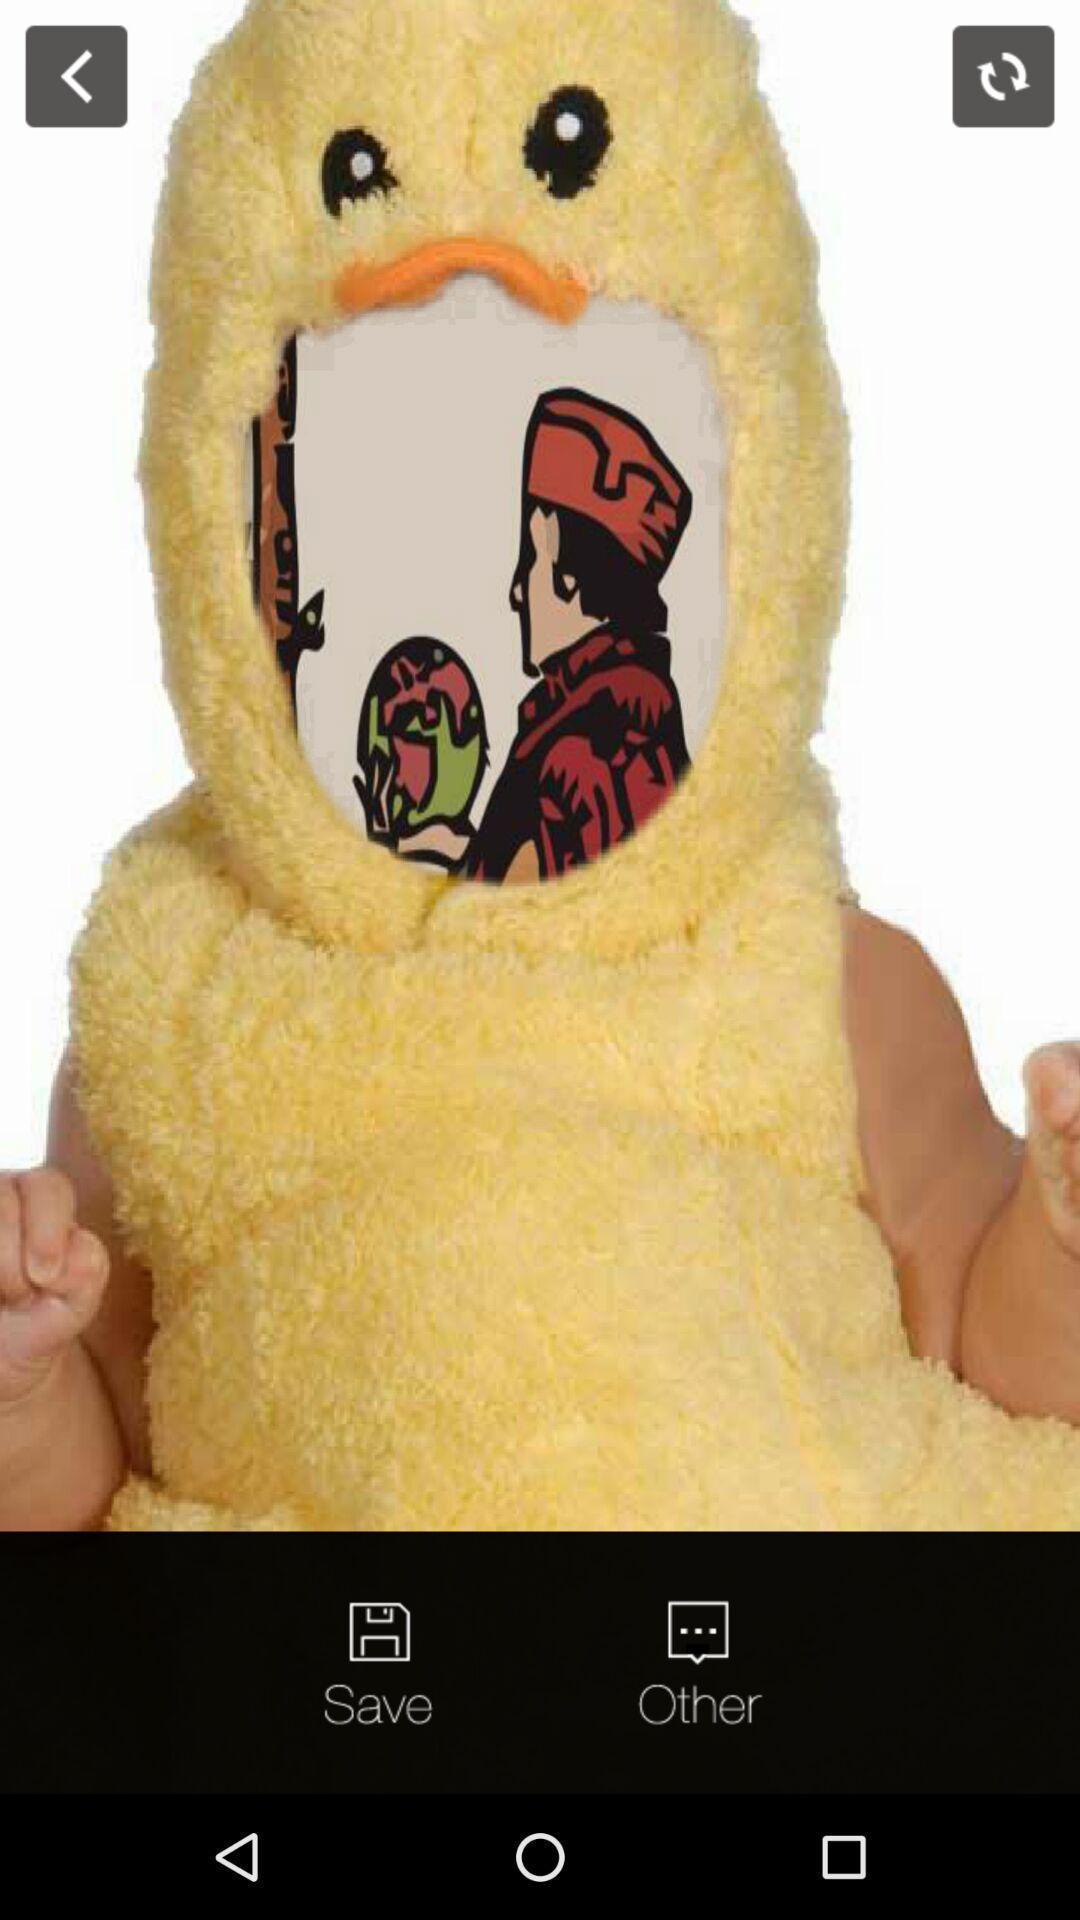What is the overall content of this screenshot? Picture page of a painting app. 